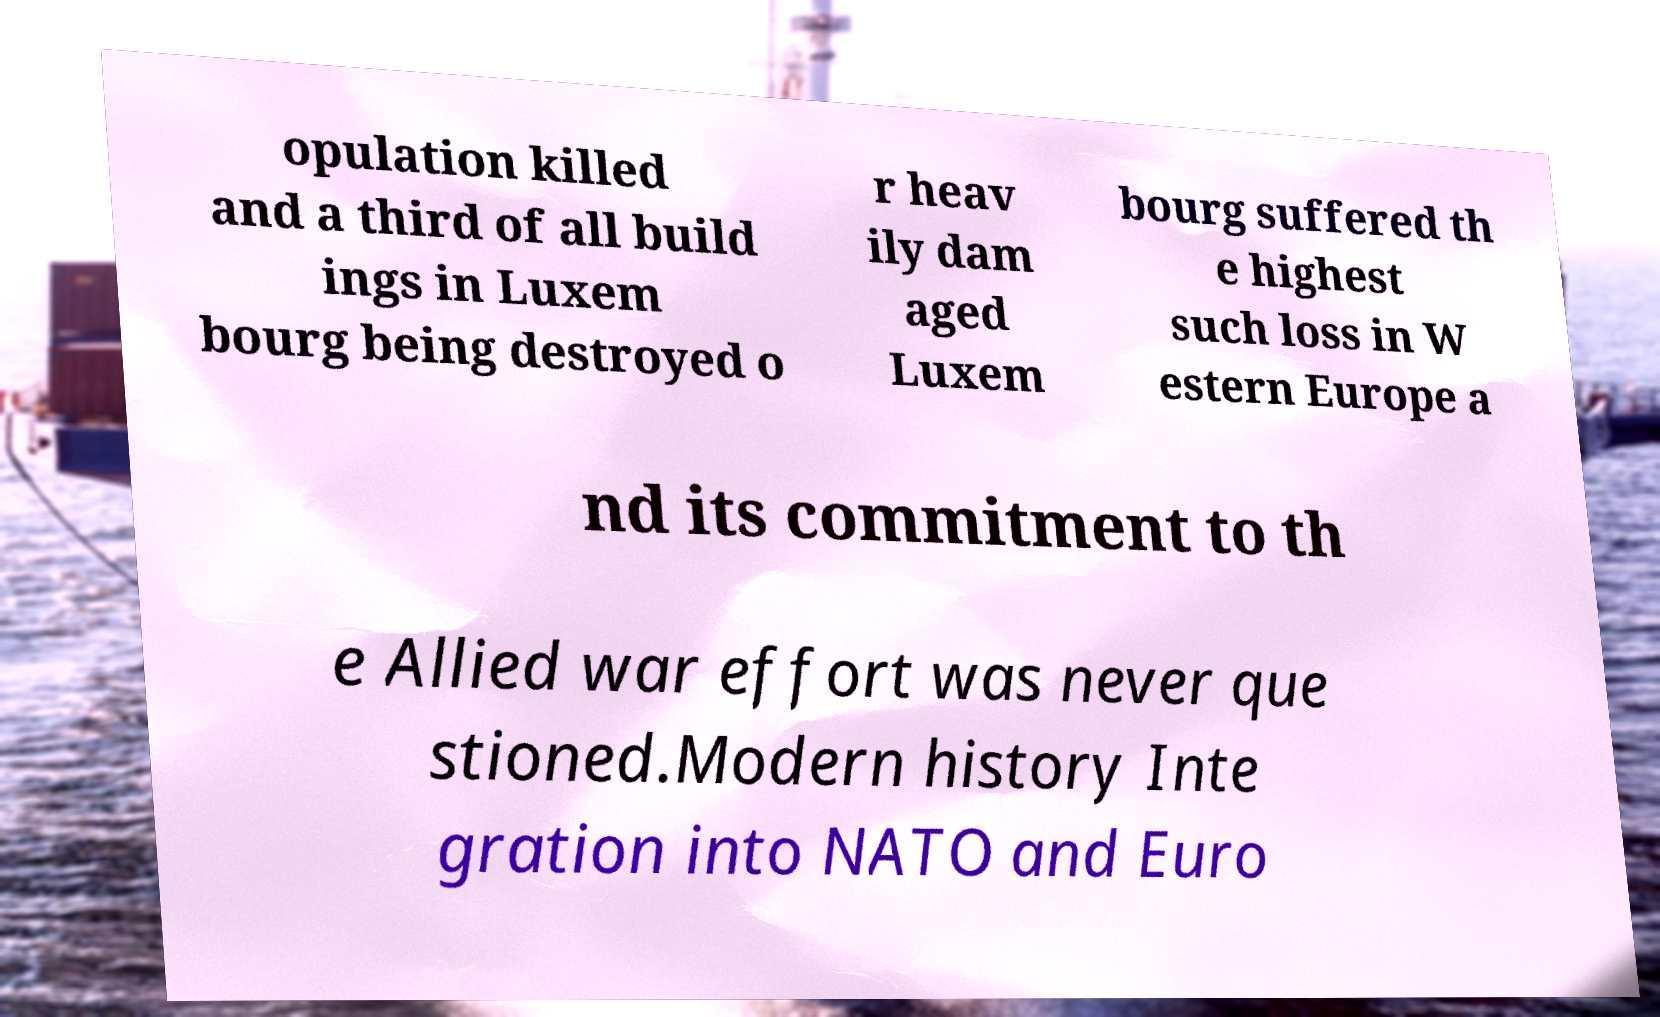Please read and relay the text visible in this image. What does it say? opulation killed and a third of all build ings in Luxem bourg being destroyed o r heav ily dam aged Luxem bourg suffered th e highest such loss in W estern Europe a nd its commitment to th e Allied war effort was never que stioned.Modern history Inte gration into NATO and Euro 